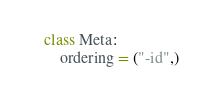<code> <loc_0><loc_0><loc_500><loc_500><_Python_>    class Meta:
        ordering = ("-id",)
</code> 